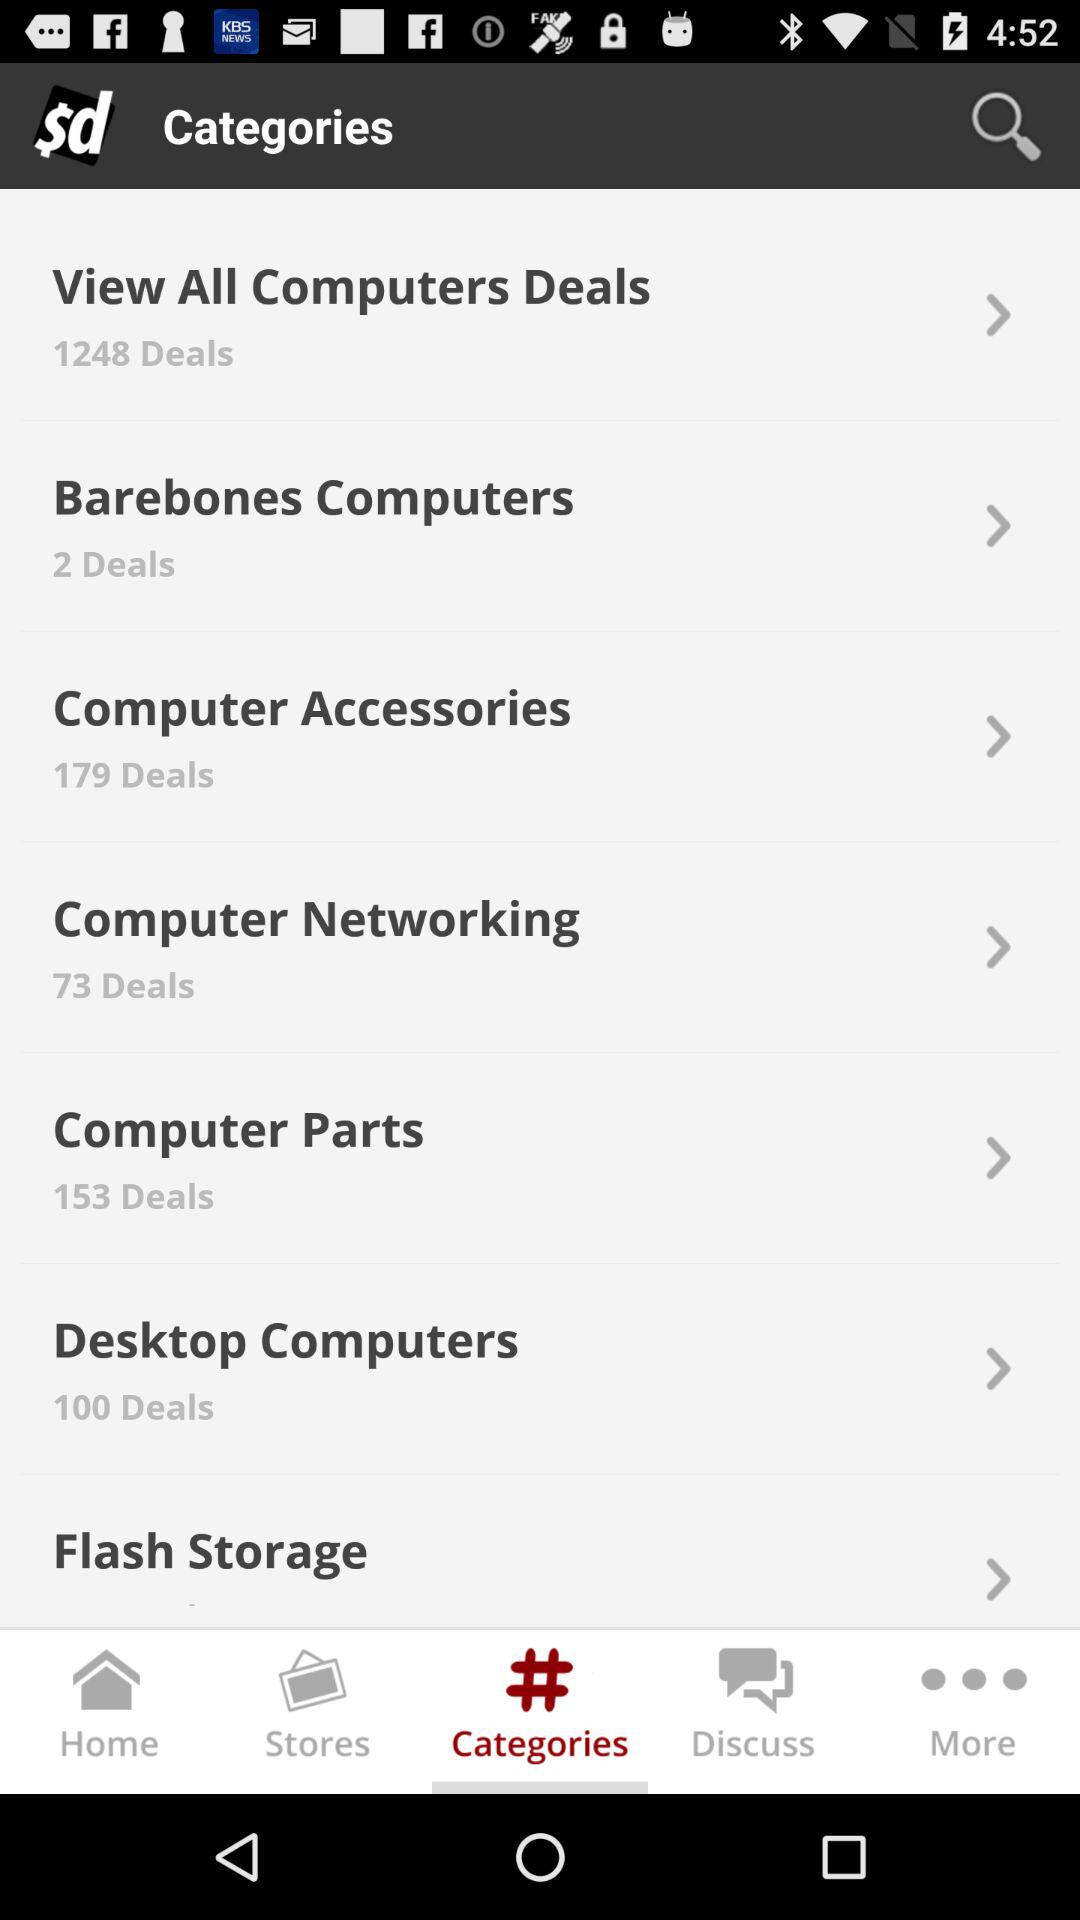How many more deals are there for computer accessories than barebones computers?
Answer the question using a single word or phrase. 177 